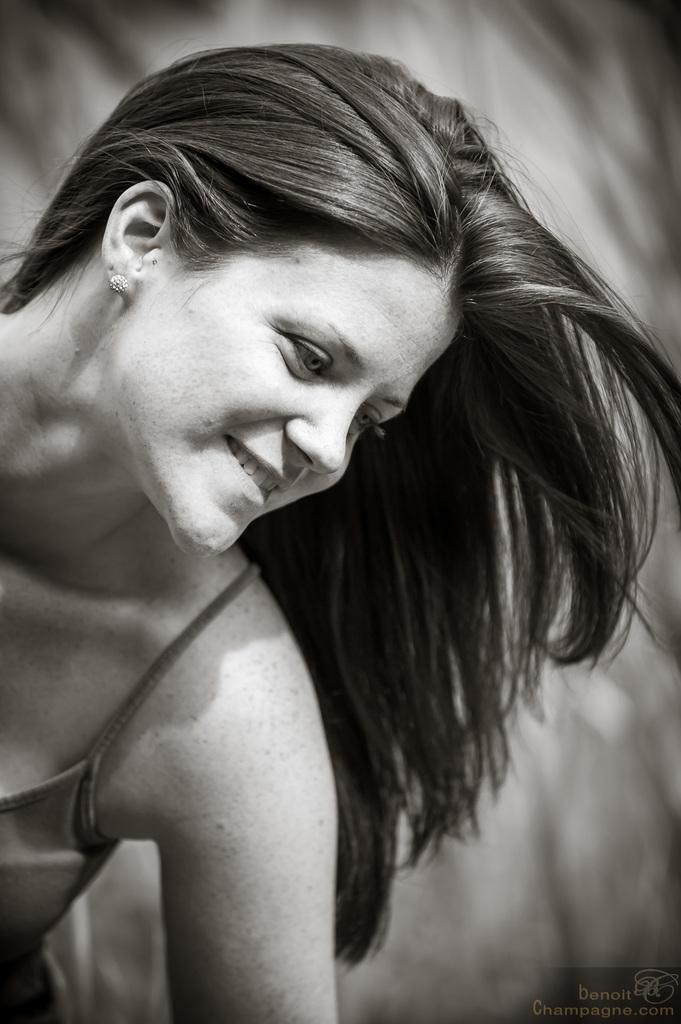What is the color scheme of the image? The image is black and white. Who is present in the image? There is a woman in the image. What is the woman's expression? The woman is smiling. What can be found in the bottom right corner of the image? There is text and a logo in the bottom right corner of the image. Can you describe the background of the image? The background of the image is not clear. What type of wave can be seen crashing on the shore in the image? There is no wave or shore present in the image; it features a woman with a black and white color scheme. What emotion does the woman express towards the person she hates in the image? There is no indication in the image that the woman hates anyone, as she is smiling. 